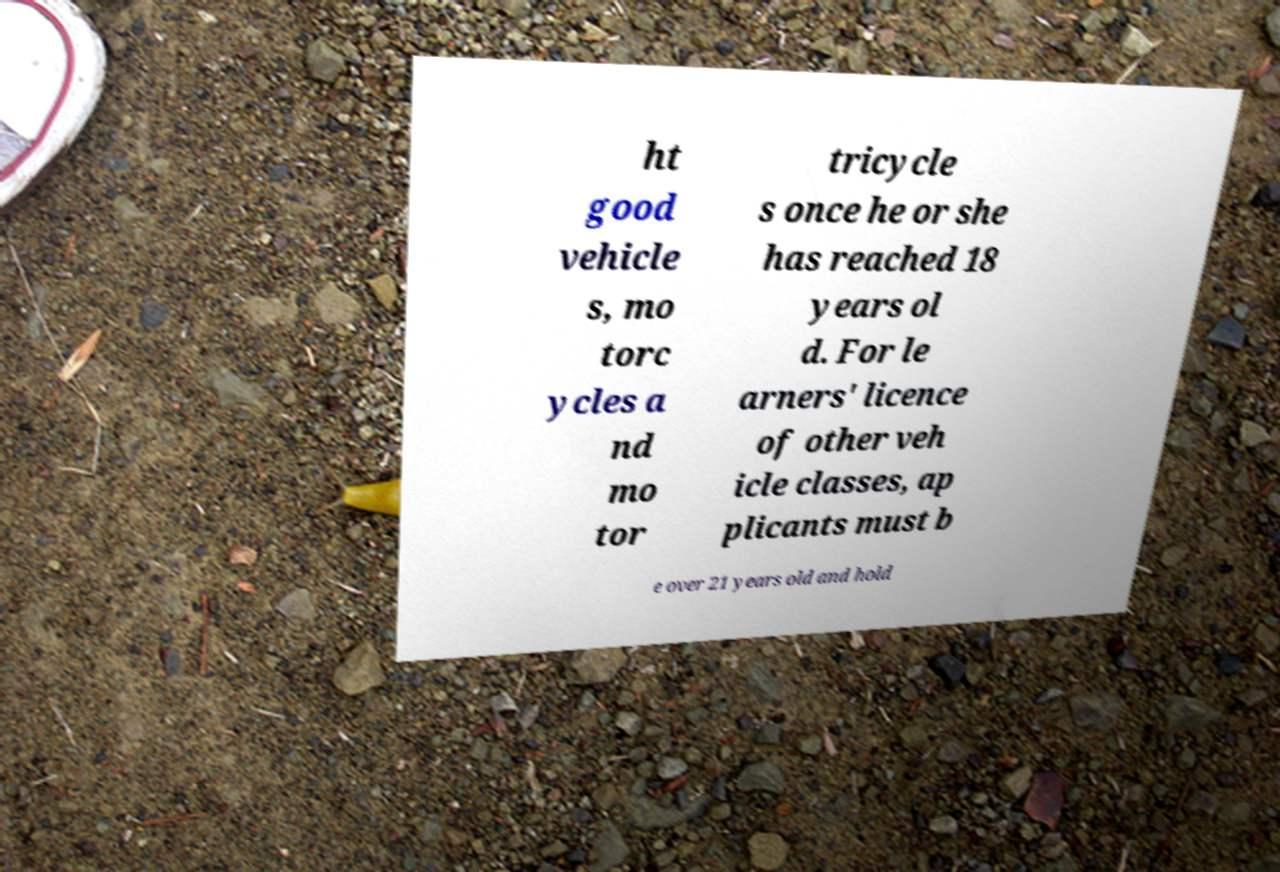I need the written content from this picture converted into text. Can you do that? ht good vehicle s, mo torc ycles a nd mo tor tricycle s once he or she has reached 18 years ol d. For le arners' licence of other veh icle classes, ap plicants must b e over 21 years old and hold 